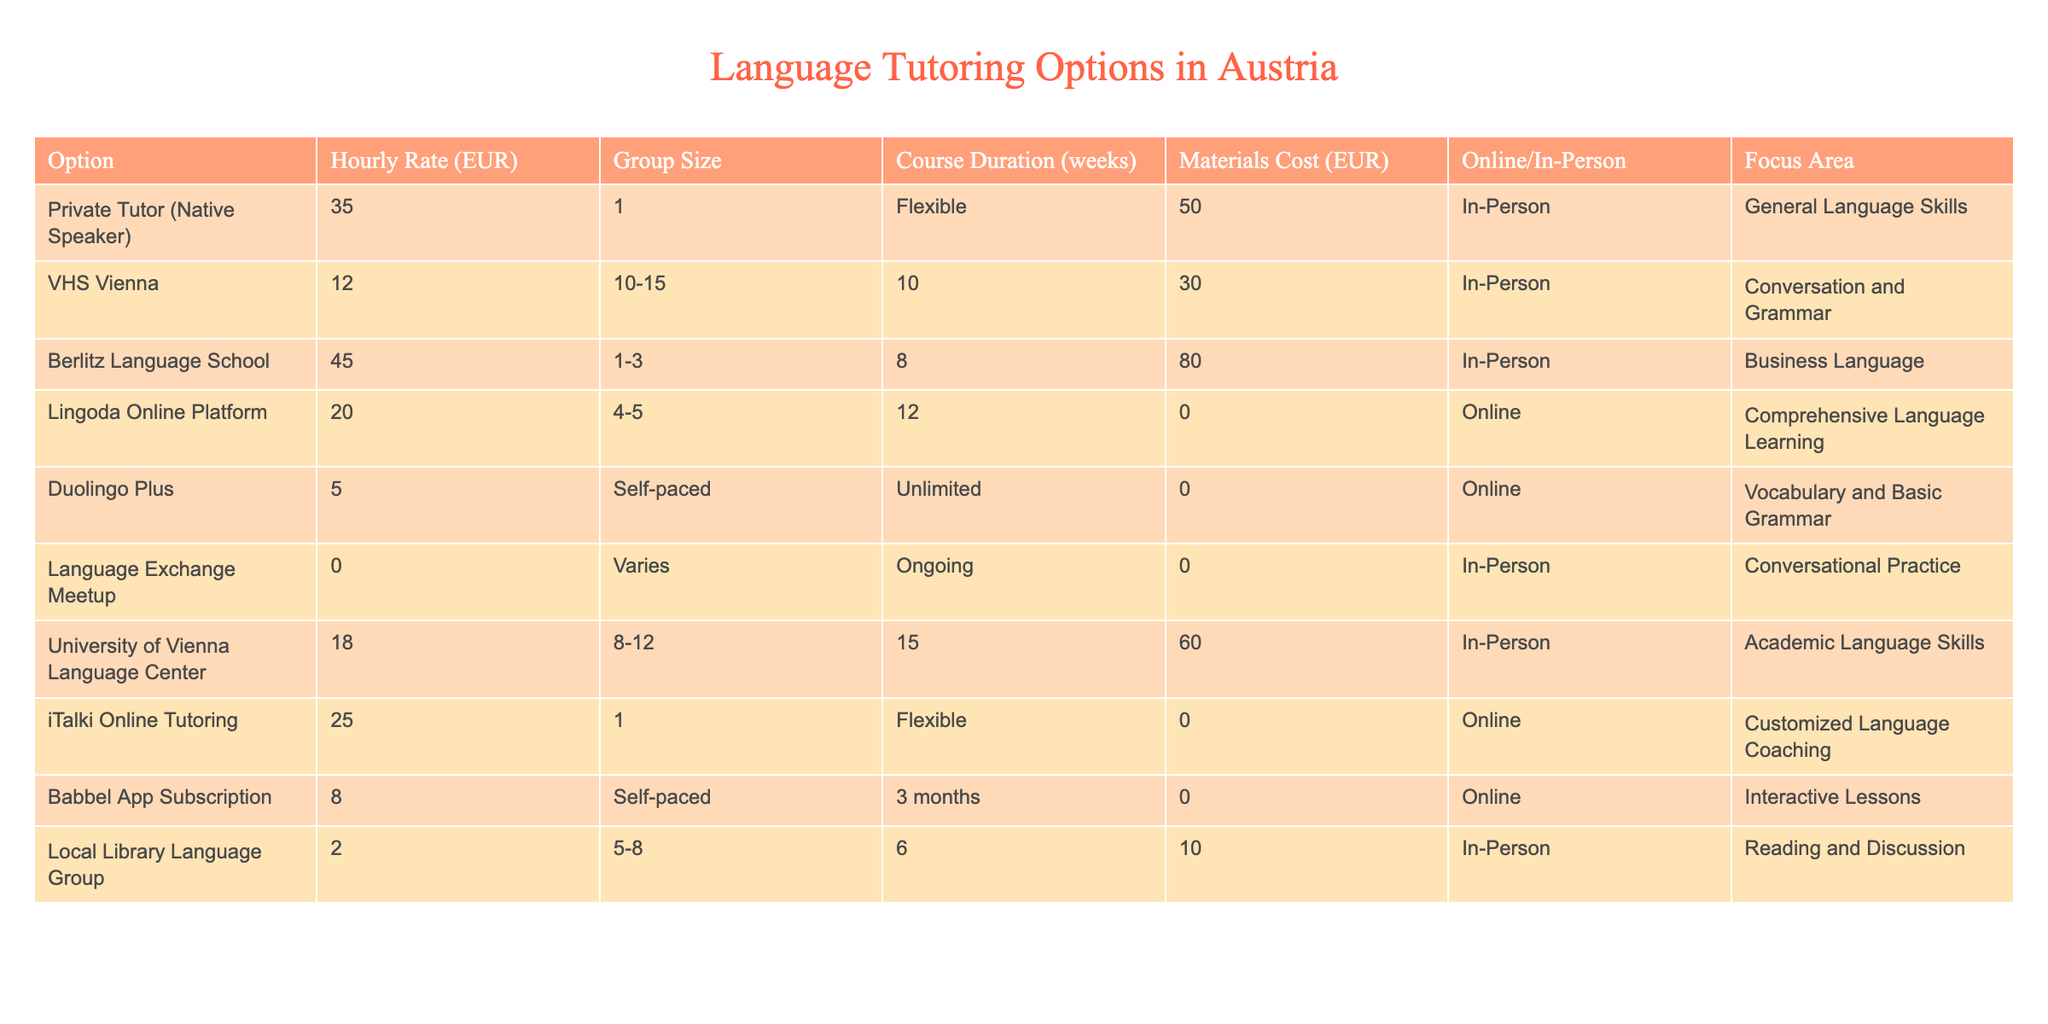What is the hourly rate for the Private Tutor (Native Speaker)? The hourly rate for the Private Tutor (Native Speaker) is listed directly in the table under the column "Hourly Rate (EUR)." The value is 35 EUR.
Answer: 35 EUR What is the materials cost for the Berlitz Language School? The materials cost for the Berlitz Language School is also found directly in the table under the column "Materials Cost (EUR)." The value is 80 EUR.
Answer: 80 EUR How many weeks does the University of Vienna Language Center course last? The duration of the course at the University of Vienna Language Center is specified in the column "Course Duration (weeks)." It states that it lasts 15 weeks.
Answer: 15 weeks Which option has the lowest hourly rate, and what is the rate? To find the lowest hourly rate, we compare the rates from each option in the "Hourly Rate (EUR)" column. The lowest value is 2 EUR from the Local Library Language Group.
Answer: Local Library Language Group, 2 EUR If a student chooses the Duolingo Plus option, what total cost would they incur for three months? The Duolingo Plus option costs 5 EUR per hour and is self-paced, meaning the cost depends on usage. Since there's no specified hourly requirement or limit, the total cost cannot be calculated as it's not fixed.
Answer: Cannot be calculated What is the average hourly rate of all options listed? To calculate the average hourly rate, sum all the hourly rates (35 + 12 + 45 + 20 + 5 + 0 + 18 + 25 + 8 + 2 = 170 EUR) and divide by the number of options (10). The average hourly rate is 170 / 10 = 17 EUR.
Answer: 17 EUR Is the Lingoda Online Platform cheaper than the VHS Vienna option? To compare, we look at the hourly rates for both options in the table. The Lingoda Online Platform has an hourly rate of 20 EUR, while the VHS Vienna has 12 EUR. Since 12 is less than 20, the statement is true.
Answer: Yes How much more does a Private Tutor (Native Speaker) cost per hour compared to the Local Library Language Group? The hourly rate for the Private Tutor is 35 EUR and for the Local Library Language Group it's 2 EUR. Subtracting these values (35 - 2), we find that the Private Tutor costs 33 EUR more per hour.
Answer: 33 EUR How many options have a materials cost of 0 EUR? We can count the number of options in the "Materials Cost (EUR)" column where the value is 0. Upon checking the data, the options are Duolingo Plus, Language Exchange Meetup, and iTalki Online Tutoring (totaling 3 options).
Answer: 3 options 